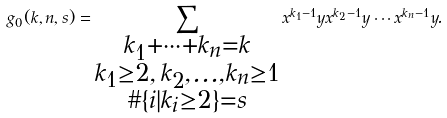<formula> <loc_0><loc_0><loc_500><loc_500>g _ { 0 } ( k , n , s ) = \sum _ { \substack { k _ { 1 } + \cdots + k _ { n } = k \\ k _ { 1 } \geq 2 , \, k _ { 2 } , \dots , k _ { n } \geq 1 \\ \# \{ i | k _ { i } \geq 2 \} = s } } x ^ { k _ { 1 } - 1 } y x ^ { k _ { 2 } - 1 } y \cdots x ^ { k _ { n } - 1 } y .</formula> 